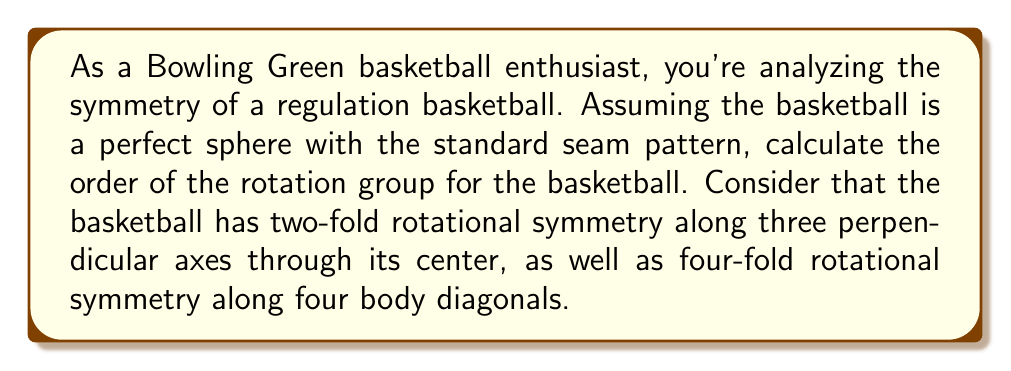Can you solve this math problem? Let's approach this step-by-step:

1) First, we need to identify all the rotational symmetries of a basketball:

   a) Three 2-fold rotations (180°) along the x, y, and z axes
   b) Four 4-fold rotations (90°, 180°, 270°) along the body diagonals
   c) The identity rotation (no rotation)

2) Let's count the number of rotations:
   
   a) 2-fold rotations: 3 axes × 1 non-trivial rotation = 3 rotations
   b) 4-fold rotations: 4 axes × 3 non-trivial rotations = 12 rotations
   c) Identity rotation: 1 rotation

3) The order of the rotation group is the total number of unique rotations:

   $$ \text{Order} = 3 + 12 + 1 = 16 $$

4) This group is actually isomorphic to the octahedral group, which is the symmetry group of a cube or octahedron.

5) In group theory notation, this group is often denoted as $O$ or $S_4$, as it's isomorphic to the symmetric group on 4 elements.
Answer: The order of the rotation group for a basketball is 16. 